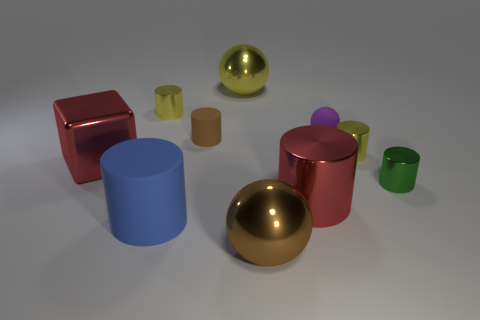There is a thing that is the same color as the big shiny block; what shape is it?
Make the answer very short. Cylinder. What is the size of the metallic thing that is the same color as the cube?
Make the answer very short. Large. What number of other things are the same shape as the small green thing?
Make the answer very short. 5. Is there anything else that has the same material as the purple thing?
Provide a short and direct response. Yes. There is a big cylinder that is to the left of the big metallic sphere in front of the big metal sphere behind the small green shiny object; what is its color?
Keep it short and to the point. Blue. There is a big red object that is on the right side of the small brown thing; does it have the same shape as the green metallic object?
Give a very brief answer. Yes. How many small purple rubber objects are there?
Offer a terse response. 1. How many yellow spheres have the same size as the brown metallic thing?
Ensure brevity in your answer.  1. What material is the small brown cylinder?
Keep it short and to the point. Rubber. Does the large matte cylinder have the same color as the big object that is on the left side of the large matte cylinder?
Ensure brevity in your answer.  No. 